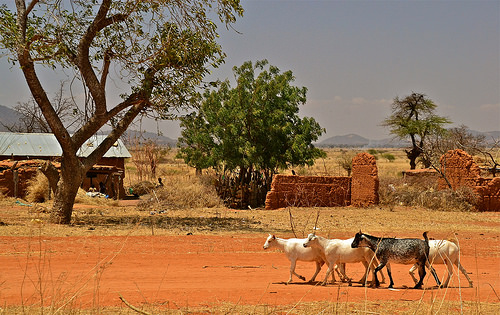<image>
Is there a animal behind the animal? No. The animal is not behind the animal. From this viewpoint, the animal appears to be positioned elsewhere in the scene. Where is the goats in relation to the tree? Is it next to the tree? No. The goats is not positioned next to the tree. They are located in different areas of the scene. 